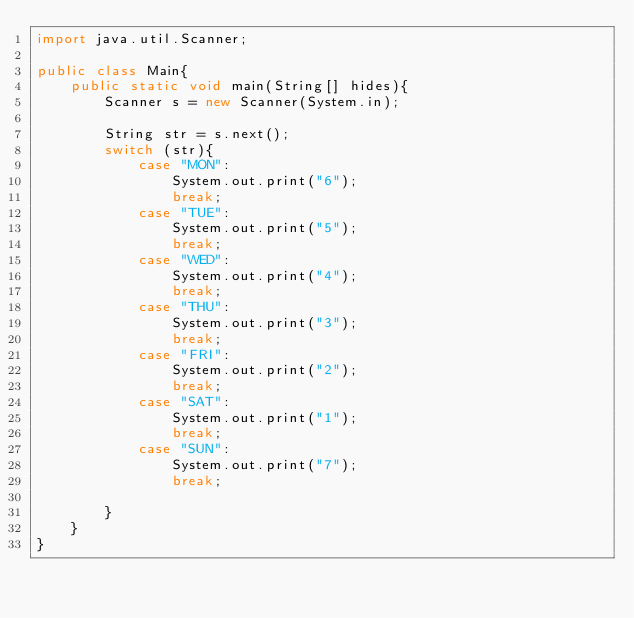<code> <loc_0><loc_0><loc_500><loc_500><_Java_>import java.util.Scanner;

public class Main{
    public static void main(String[] hides){
        Scanner s = new Scanner(System.in);

        String str = s.next();
        switch (str){
            case "MON":
                System.out.print("6");
                break;
            case "TUE":
                System.out.print("5");
                break;
            case "WED":
                System.out.print("4");
                break;
            case "THU":
                System.out.print("3");
                break;
            case "FRI":
                System.out.print("2");
                break;
            case "SAT":
                System.out.print("1");
                break;
            case "SUN":
                System.out.print("7");
                break;

        }
    }
}
</code> 